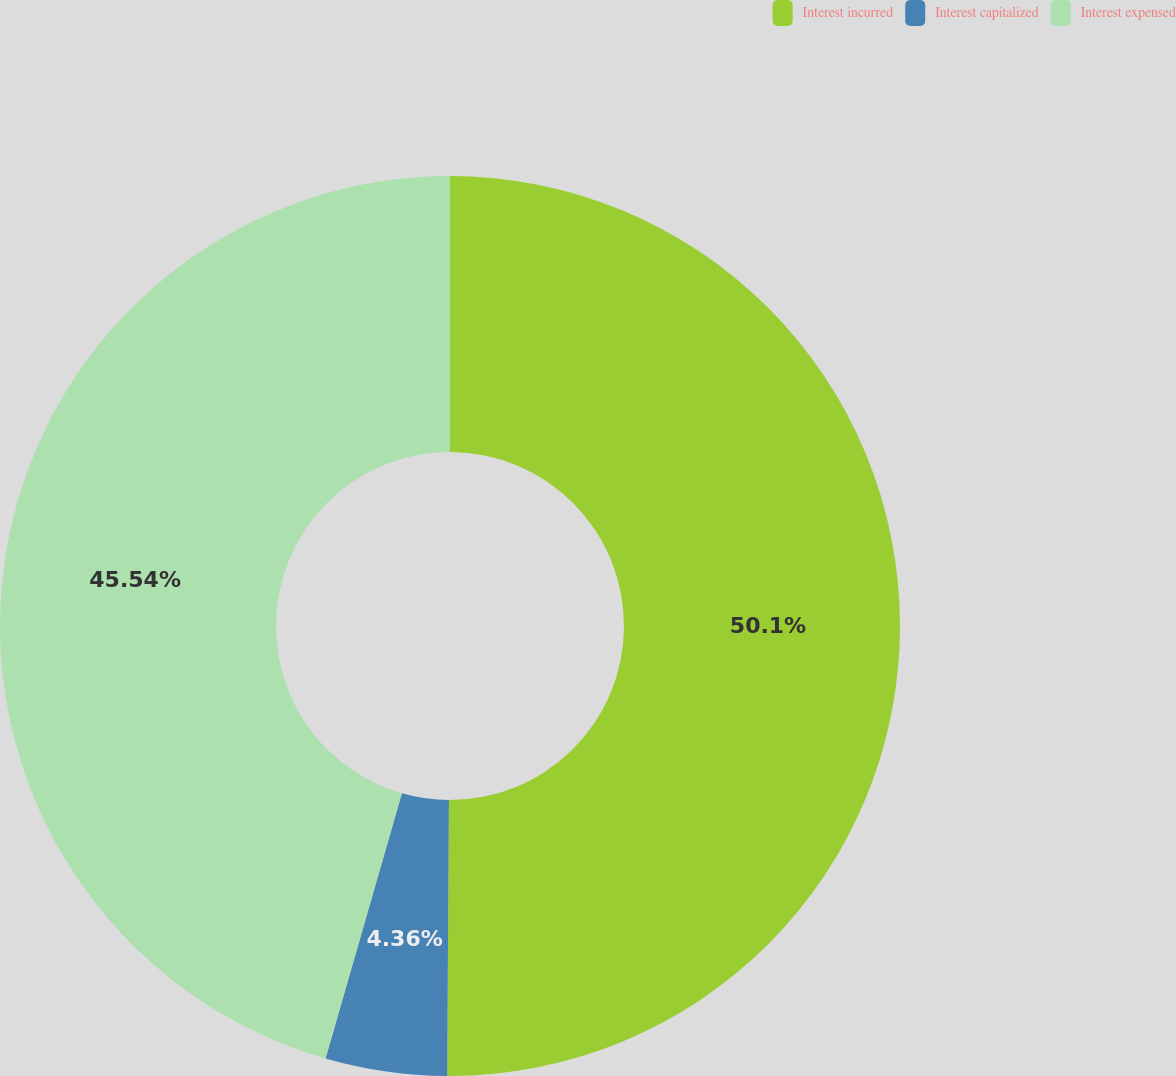Convert chart to OTSL. <chart><loc_0><loc_0><loc_500><loc_500><pie_chart><fcel>Interest incurred<fcel>Interest capitalized<fcel>Interest expensed<nl><fcel>50.1%<fcel>4.36%<fcel>45.54%<nl></chart> 